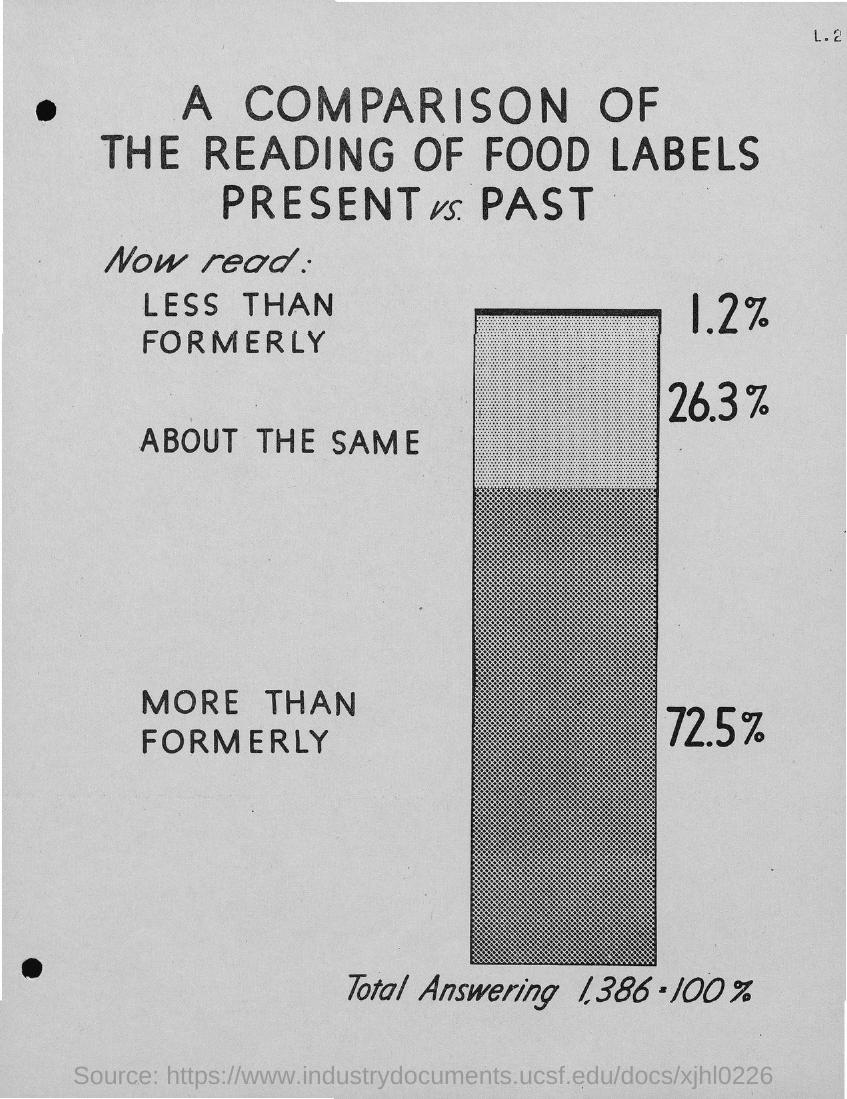Point out several critical features in this image. The document provides a comparison between the reading of food labels present and past. 